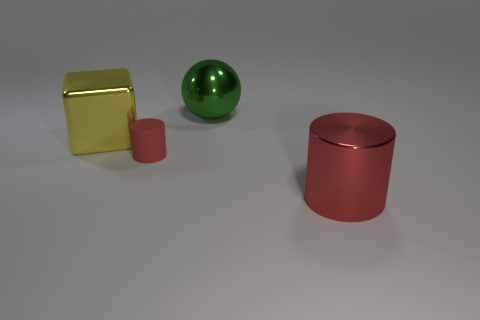Add 4 tiny red objects. How many objects exist? 8 Subtract all spheres. How many objects are left? 3 Subtract 0 red cubes. How many objects are left? 4 Subtract all green matte balls. Subtract all balls. How many objects are left? 3 Add 3 yellow shiny cubes. How many yellow shiny cubes are left? 4 Add 1 large blue matte spheres. How many large blue matte spheres exist? 1 